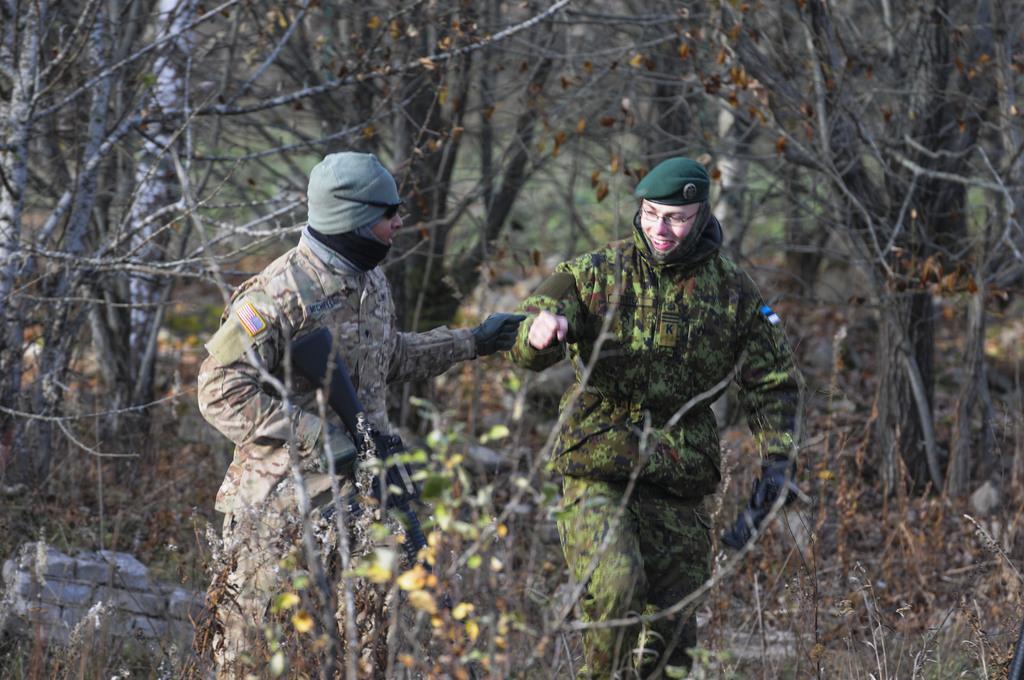Please provide a concise description of this image. In this image in front there are two persons holding the guns. In the background there are trees. 